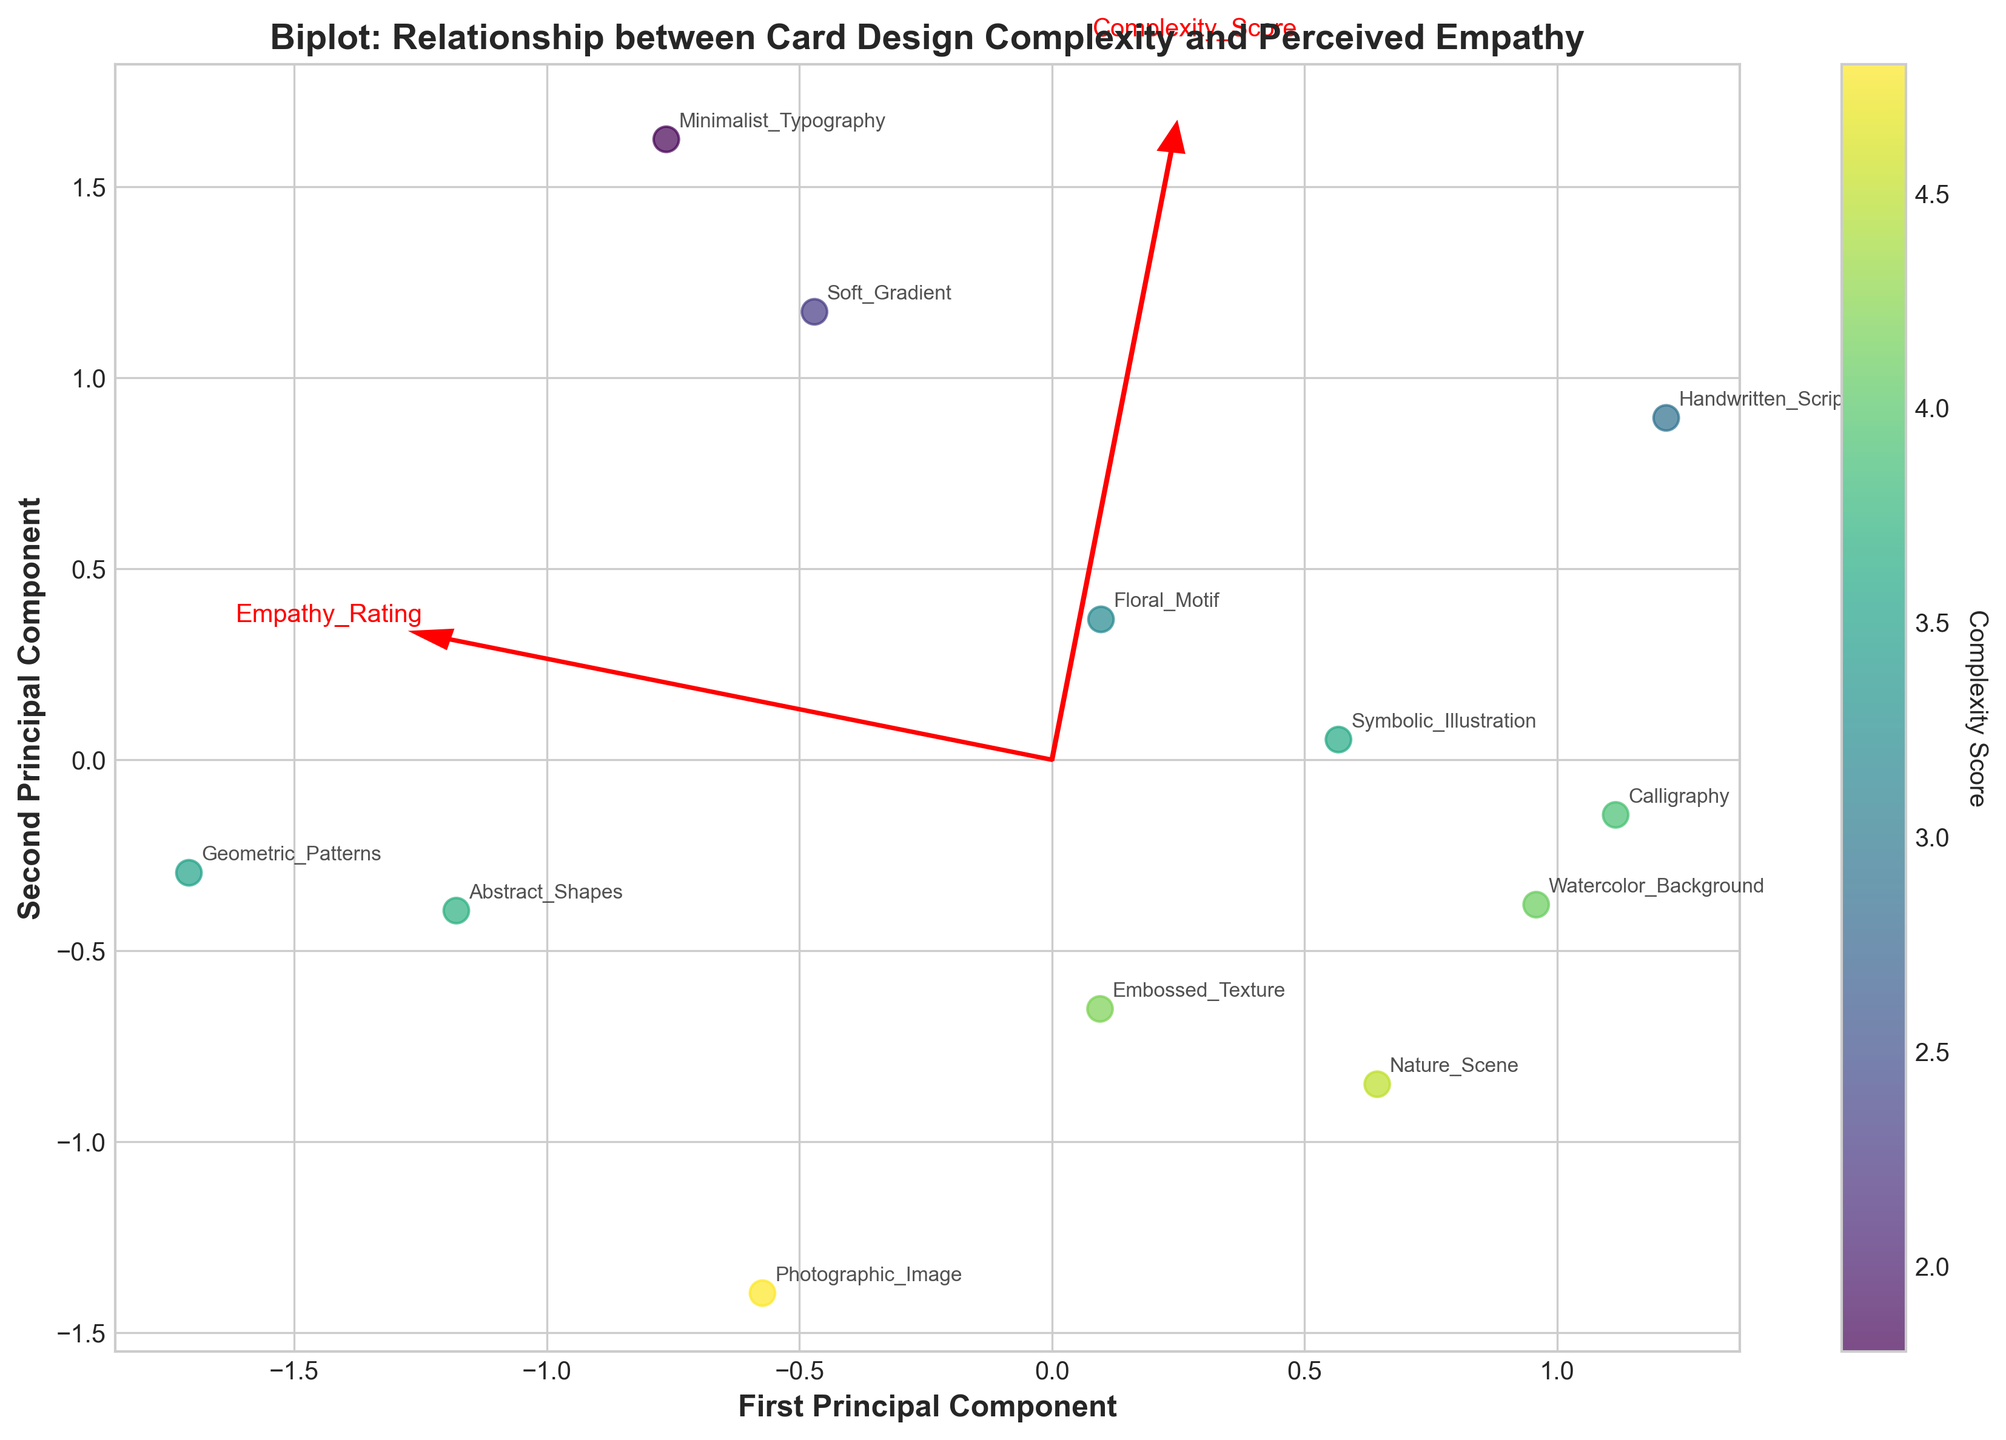What is the title of the plot? The title is shown at the top of the plot, and it's usually in bold font to draw attention. For this plot, the title is "Biplot: Relationship between Card Design Complexity and Perceived Empathy".
Answer: Biplot: Relationship between Card Design Complexity and Perceived Empathy How many design elements are represented in the plot? The number of data points (scatter points) on the plot corresponds to the number of design elements. By counting these, we can see there are 12 design elements represented.
Answer: 12 Which design element has the highest perceived empathy rating? By looking at the Y-axis which represents perceived empathy and identifying the highest point on that axis, the design element 'Handwritten Script' is placed the highest.
Answer: Handwritten Script What color represents the highest complexity score? The color map ('viridis') is shown, with lighter colors representing higher values as indicated by the color bar. The light green-yellow color indicates the highest complexity score.
Answer: Light green-yellow In which quadrant of the plot does 'Calligraphy' fall? By observing the placement of 'Calligraphy' in relation to the origin (0,0), it's in the top right quadrant (positive values on both the first and second principal components).
Answer: Top right Which design elements have a higher complexity score than 'Minimalist Typography'? By comparing positions relative to the X-axis where 'Minimalist Typography' is placed, those placed to the right have a higher complexity score. These elements are 'Floral Motif', 'Watercolor Background', 'Abstract Shapes', 'Nature Scene', 'Geometric Patterns', 'Photographic Image', 'Calligraphy', 'Embossed Texture', and 'Symbolic Illustration'.
Answer: Floral Motif, Watercolor Background, Abstract Shapes, Nature Scene, Geometric Patterns, Photographic Image, Calligraphy, Embossed Texture, Symbolic Illustration Which data point has the lowest empathy rating? By looking at the lowest position on the Y-axis, the point corresponding to the design element 'Geometric Patterns' is the lowest.
Answer: Geometric Patterns Which variable contributes more to the first principal component? The length of the vectors from the origin helps us determine this. The vector length for 'Complexity Score' (first component) is longer compared to 'Empathy Rating' (second component).
Answer: Complexity Score Is there a negative correlation visible between the complexity score and the perceived empathy rating? By examining the directions and spread of the data points, there does not appear to be a clear negative correlation as points are distributed in a more scattered manner.
Answer: No Does 'Photographic Image' have a higher or lower complexity score compared to 'Abstract Shapes'? By observing the positions relative to the X-axis, 'Photographic Image' is further right compared to 'Abstract Shapes', indicating a higher complexity score.
Answer: Higher 